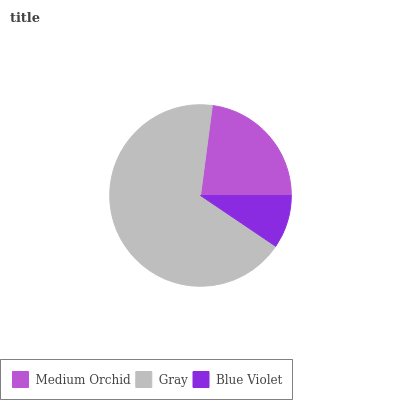Is Blue Violet the minimum?
Answer yes or no. Yes. Is Gray the maximum?
Answer yes or no. Yes. Is Gray the minimum?
Answer yes or no. No. Is Blue Violet the maximum?
Answer yes or no. No. Is Gray greater than Blue Violet?
Answer yes or no. Yes. Is Blue Violet less than Gray?
Answer yes or no. Yes. Is Blue Violet greater than Gray?
Answer yes or no. No. Is Gray less than Blue Violet?
Answer yes or no. No. Is Medium Orchid the high median?
Answer yes or no. Yes. Is Medium Orchid the low median?
Answer yes or no. Yes. Is Blue Violet the high median?
Answer yes or no. No. Is Gray the low median?
Answer yes or no. No. 